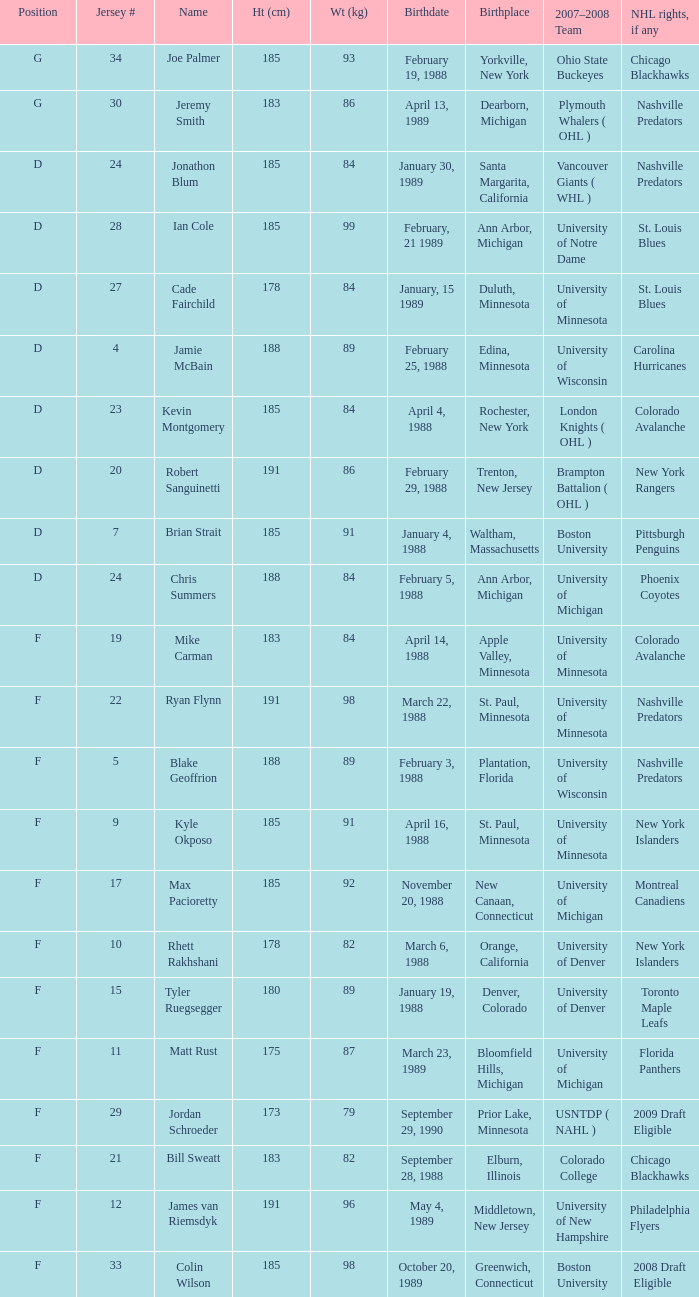Which Height (cm) has a Birthplace of new canaan, connecticut? 1.0. 